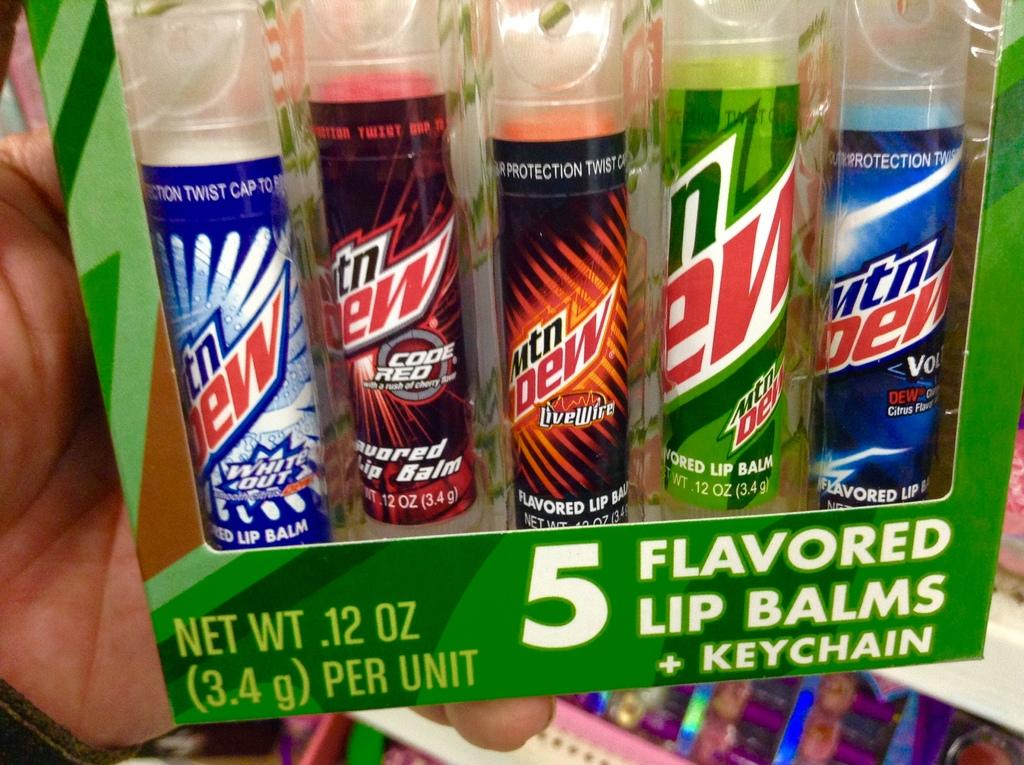Provide a one-sentence caption for the provided image. A case of Mountain Dew Lip Balms and a keychain. 